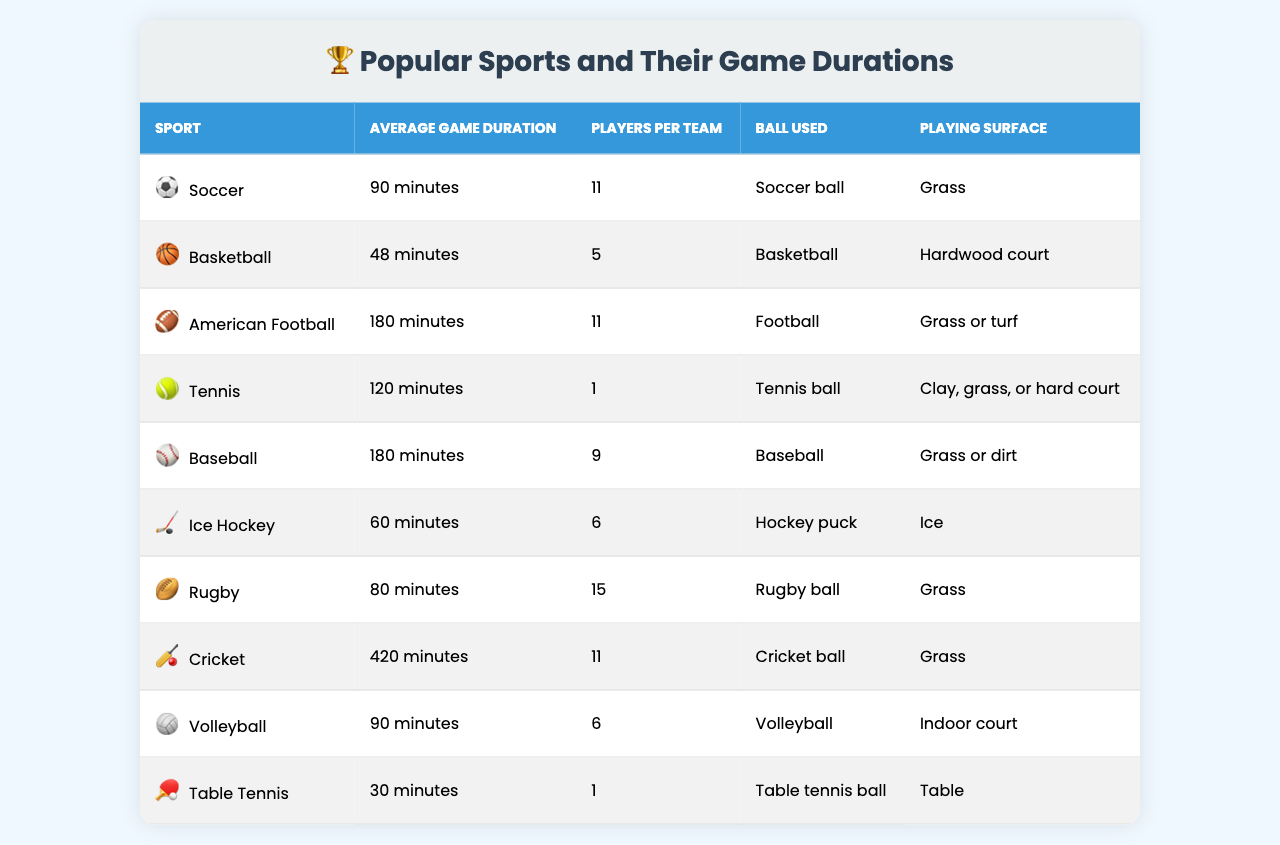What is the average game duration for soccer? The table shows that the average game duration for soccer is listed under "Average Game Duration (minutes)" next to "Soccer." The value is 90 minutes.
Answer: 90 minutes Which sport has the longest average game duration? The table indicates that cricket has the longest average game duration, which is 420 minutes.
Answer: Cricket How many players are there per team in basketball? Looking at the "Number of Players per Team" column, basketball has 5 players per team listed next to it.
Answer: 5 players Is the ball used in rugby a football? The table specifies that the ball used in rugby is a "Rugby ball," not a football. Therefore, the statement is false.
Answer: No What is the average game duration of volleyball compared to ice hockey? Volleyball has an average game duration of 90 minutes, while ice hockey has 60 minutes. Comparing these values, volleyball lasts longer by 30 minutes.
Answer: Volleyball is longer by 30 minutes If you add the average game durations of soccer and tennis, what is the total? The average durations for soccer (90 minutes) and tennis (120 minutes) are summed: 90 + 120 = 210.
Answer: 210 minutes What percentage of players per team in American football do rugby and soccer have in common? Rugby and soccer both have 11 players per team. Since both sports have the same number, the percentage of common players is 100%.
Answer: 100% Which sport has the same playing surface as soccer, and how many players are on each team? Both rugby and soccer are played on grass. Rugby has 15 players per team, while soccer has 11 players per team.
Answer: Rugby has 15 players; Soccer has 11 players Are there any sports listed that use a ball other than a round ball? The table indicates that ice hockey uses a "Hockey puck," which is not a round ball. This confirms there is at least one sport that uses a different type of ball.
Answer: Yes What is the average game duration for all sports listed in the table? To find the average, we sum the average durations: 90 + 48 + 180 + 120 + 180 + 60 + 80 + 420 + 90 + 30 = 1,278 minutes. There are 10 sports, so the average is 1,278 / 10 = 127.8 minutes.
Answer: 127.8 minutes 